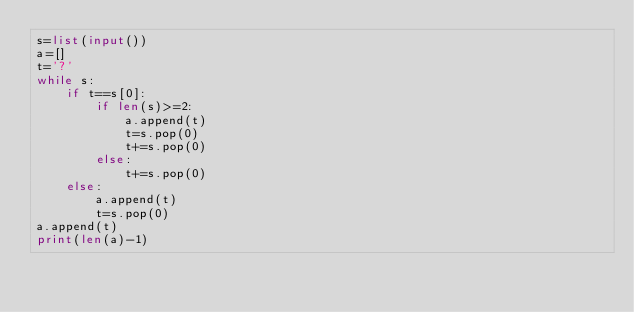<code> <loc_0><loc_0><loc_500><loc_500><_Python_>s=list(input())
a=[]
t='?'
while s:
    if t==s[0]:
        if len(s)>=2:
            a.append(t)
            t=s.pop(0)
            t+=s.pop(0)
        else:
            t+=s.pop(0)
    else:
        a.append(t)
        t=s.pop(0)
a.append(t)
print(len(a)-1)
</code> 